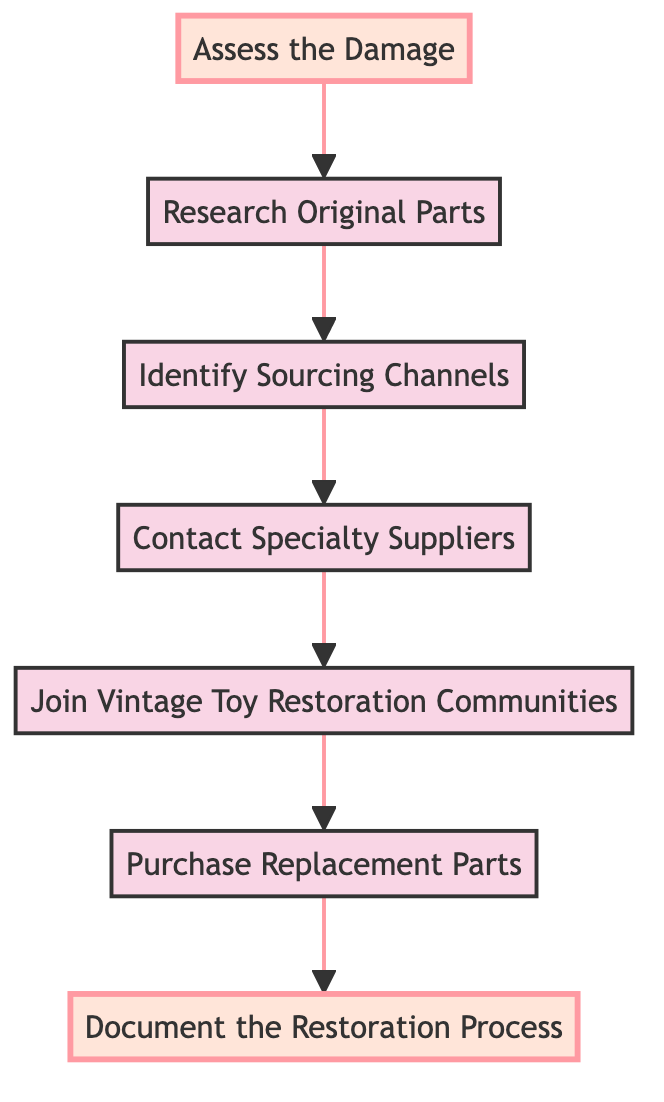What is the first step in the flowchart? The diagram starts with the step "Assess the Damage." It is the initial point of the flow, leading to the next step.
Answer: Assess the Damage How many steps are there in total? By counting all the steps listed in the diagram, we find there are 7 steps in total from "Assess the Damage" to "Document the Restoration Process."
Answer: 7 What is the last step in the flowchart? The last step of the flowchart is "Document the Restoration Process," which concludes the process after all previous steps have been completed.
Answer: Document the Restoration Process Which steps lead directly to "Purchase Replacement Parts"? The step "Join Vintage Toy Restoration Communities" leads directly to "Purchase Replacement Parts," indicating a flow where community engagement informs purchasing decisions.
Answer: Join Vintage Toy Restoration Communities What two actions are taken before contacting specialty suppliers? The actions "Research Original Parts" and "Identify Sourcing Channels" must both be completed before moving on to "Contact Specialty Suppliers." This indicates a preparatory phase for sourcing.
Answer: Research Original Parts, Identify Sourcing Channels In which step are vintage toy restoration communities engaged? The step titled "Join Vintage Toy Restoration Communities" specifically highlights the engagement with such groups as part of the sourcing process.
Answer: Join Vintage Toy Restoration Communities How many sourcing channels should be identified? The diagram suggests to identify sourcing channels without specifying an exact number, indicating that multiple channels should be considered. Therefore, the answer is implied to be "multiple."
Answer: Multiple What is the purpose of documenting the restoration process? The step "Document the Restoration Process" serves the purpose of keeping detailed notes for future reference, ensuring that the restoration details are clearly recorded.
Answer: Future reference Which step directly follows "Identify Sourcing Channels"? The step that follows "Identify Sourcing Channels" is "Contact Specialty Suppliers," showing a sequential action based on channel identification.
Answer: Contact Specialty Suppliers Which step is highlighted at the beginning of the flowchart? "Assess the Damage" is the initial highlighted step, indicating its importance as the starting point of the restoration process.
Answer: Assess the Damage 